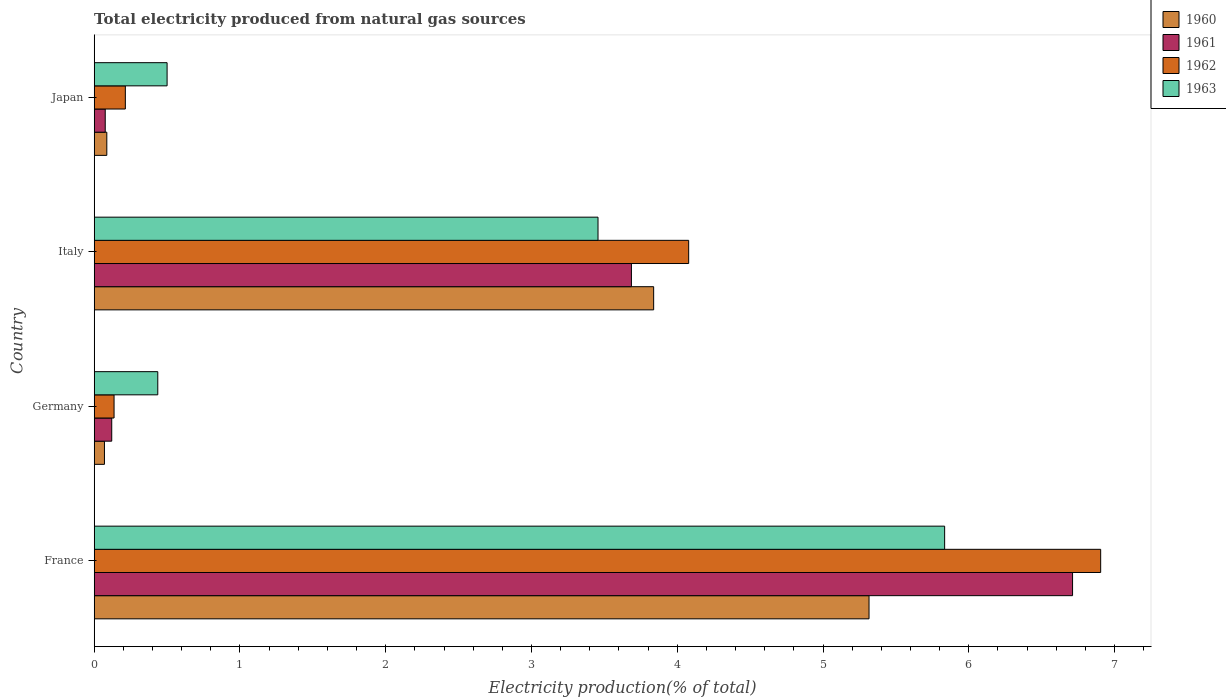How many different coloured bars are there?
Offer a terse response. 4. Are the number of bars per tick equal to the number of legend labels?
Make the answer very short. Yes. Are the number of bars on each tick of the Y-axis equal?
Your response must be concise. Yes. How many bars are there on the 2nd tick from the top?
Your answer should be compact. 4. What is the total electricity produced in 1960 in Germany?
Provide a short and direct response. 0.07. Across all countries, what is the maximum total electricity produced in 1960?
Keep it short and to the point. 5.32. Across all countries, what is the minimum total electricity produced in 1963?
Provide a short and direct response. 0.44. In which country was the total electricity produced in 1961 maximum?
Your answer should be compact. France. What is the total total electricity produced in 1961 in the graph?
Your response must be concise. 10.59. What is the difference between the total electricity produced in 1963 in France and that in Japan?
Your answer should be very brief. 5.33. What is the difference between the total electricity produced in 1960 in France and the total electricity produced in 1962 in Italy?
Provide a short and direct response. 1.24. What is the average total electricity produced in 1962 per country?
Your response must be concise. 2.83. What is the difference between the total electricity produced in 1963 and total electricity produced in 1962 in Germany?
Offer a terse response. 0.3. In how many countries, is the total electricity produced in 1963 greater than 0.2 %?
Keep it short and to the point. 4. What is the ratio of the total electricity produced in 1963 in Germany to that in Japan?
Your answer should be very brief. 0.87. Is the total electricity produced in 1961 in France less than that in Germany?
Offer a terse response. No. Is the difference between the total electricity produced in 1963 in Germany and Italy greater than the difference between the total electricity produced in 1962 in Germany and Italy?
Offer a very short reply. Yes. What is the difference between the highest and the second highest total electricity produced in 1962?
Keep it short and to the point. 2.83. What is the difference between the highest and the lowest total electricity produced in 1963?
Your answer should be very brief. 5.4. Is the sum of the total electricity produced in 1962 in France and Germany greater than the maximum total electricity produced in 1961 across all countries?
Make the answer very short. Yes. What does the 1st bar from the bottom in France represents?
Offer a very short reply. 1960. Is it the case that in every country, the sum of the total electricity produced in 1960 and total electricity produced in 1961 is greater than the total electricity produced in 1962?
Provide a succinct answer. No. Are all the bars in the graph horizontal?
Give a very brief answer. Yes. How many countries are there in the graph?
Your answer should be very brief. 4. What is the difference between two consecutive major ticks on the X-axis?
Your answer should be compact. 1. Are the values on the major ticks of X-axis written in scientific E-notation?
Your answer should be very brief. No. Does the graph contain grids?
Keep it short and to the point. No. What is the title of the graph?
Your answer should be very brief. Total electricity produced from natural gas sources. Does "1984" appear as one of the legend labels in the graph?
Keep it short and to the point. No. What is the label or title of the X-axis?
Provide a short and direct response. Electricity production(% of total). What is the label or title of the Y-axis?
Provide a short and direct response. Country. What is the Electricity production(% of total) of 1960 in France?
Your answer should be very brief. 5.32. What is the Electricity production(% of total) of 1961 in France?
Make the answer very short. 6.71. What is the Electricity production(% of total) in 1962 in France?
Offer a terse response. 6.91. What is the Electricity production(% of total) in 1963 in France?
Give a very brief answer. 5.83. What is the Electricity production(% of total) in 1960 in Germany?
Provide a succinct answer. 0.07. What is the Electricity production(% of total) in 1961 in Germany?
Provide a succinct answer. 0.12. What is the Electricity production(% of total) of 1962 in Germany?
Your response must be concise. 0.14. What is the Electricity production(% of total) in 1963 in Germany?
Keep it short and to the point. 0.44. What is the Electricity production(% of total) of 1960 in Italy?
Make the answer very short. 3.84. What is the Electricity production(% of total) of 1961 in Italy?
Offer a very short reply. 3.69. What is the Electricity production(% of total) of 1962 in Italy?
Provide a short and direct response. 4.08. What is the Electricity production(% of total) of 1963 in Italy?
Your answer should be compact. 3.46. What is the Electricity production(% of total) of 1960 in Japan?
Keep it short and to the point. 0.09. What is the Electricity production(% of total) of 1961 in Japan?
Make the answer very short. 0.08. What is the Electricity production(% of total) of 1962 in Japan?
Provide a succinct answer. 0.21. What is the Electricity production(% of total) of 1963 in Japan?
Your response must be concise. 0.5. Across all countries, what is the maximum Electricity production(% of total) in 1960?
Offer a terse response. 5.32. Across all countries, what is the maximum Electricity production(% of total) of 1961?
Your answer should be very brief. 6.71. Across all countries, what is the maximum Electricity production(% of total) in 1962?
Provide a short and direct response. 6.91. Across all countries, what is the maximum Electricity production(% of total) in 1963?
Your answer should be compact. 5.83. Across all countries, what is the minimum Electricity production(% of total) of 1960?
Your answer should be compact. 0.07. Across all countries, what is the minimum Electricity production(% of total) in 1961?
Give a very brief answer. 0.08. Across all countries, what is the minimum Electricity production(% of total) of 1962?
Your response must be concise. 0.14. Across all countries, what is the minimum Electricity production(% of total) of 1963?
Your answer should be very brief. 0.44. What is the total Electricity production(% of total) in 1960 in the graph?
Your response must be concise. 9.31. What is the total Electricity production(% of total) of 1961 in the graph?
Ensure brevity in your answer.  10.59. What is the total Electricity production(% of total) in 1962 in the graph?
Your response must be concise. 11.33. What is the total Electricity production(% of total) of 1963 in the graph?
Give a very brief answer. 10.23. What is the difference between the Electricity production(% of total) of 1960 in France and that in Germany?
Keep it short and to the point. 5.25. What is the difference between the Electricity production(% of total) in 1961 in France and that in Germany?
Give a very brief answer. 6.59. What is the difference between the Electricity production(% of total) in 1962 in France and that in Germany?
Ensure brevity in your answer.  6.77. What is the difference between the Electricity production(% of total) of 1963 in France and that in Germany?
Your response must be concise. 5.4. What is the difference between the Electricity production(% of total) of 1960 in France and that in Italy?
Your answer should be compact. 1.48. What is the difference between the Electricity production(% of total) in 1961 in France and that in Italy?
Provide a succinct answer. 3.03. What is the difference between the Electricity production(% of total) in 1962 in France and that in Italy?
Give a very brief answer. 2.83. What is the difference between the Electricity production(% of total) in 1963 in France and that in Italy?
Make the answer very short. 2.38. What is the difference between the Electricity production(% of total) of 1960 in France and that in Japan?
Make the answer very short. 5.23. What is the difference between the Electricity production(% of total) of 1961 in France and that in Japan?
Offer a very short reply. 6.64. What is the difference between the Electricity production(% of total) in 1962 in France and that in Japan?
Your answer should be compact. 6.69. What is the difference between the Electricity production(% of total) of 1963 in France and that in Japan?
Offer a terse response. 5.33. What is the difference between the Electricity production(% of total) of 1960 in Germany and that in Italy?
Provide a succinct answer. -3.77. What is the difference between the Electricity production(% of total) in 1961 in Germany and that in Italy?
Offer a very short reply. -3.57. What is the difference between the Electricity production(% of total) in 1962 in Germany and that in Italy?
Your answer should be compact. -3.94. What is the difference between the Electricity production(% of total) in 1963 in Germany and that in Italy?
Provide a short and direct response. -3.02. What is the difference between the Electricity production(% of total) of 1960 in Germany and that in Japan?
Make the answer very short. -0.02. What is the difference between the Electricity production(% of total) of 1961 in Germany and that in Japan?
Make the answer very short. 0.04. What is the difference between the Electricity production(% of total) of 1962 in Germany and that in Japan?
Provide a succinct answer. -0.08. What is the difference between the Electricity production(% of total) in 1963 in Germany and that in Japan?
Offer a very short reply. -0.06. What is the difference between the Electricity production(% of total) of 1960 in Italy and that in Japan?
Your response must be concise. 3.75. What is the difference between the Electricity production(% of total) of 1961 in Italy and that in Japan?
Keep it short and to the point. 3.61. What is the difference between the Electricity production(% of total) in 1962 in Italy and that in Japan?
Offer a very short reply. 3.86. What is the difference between the Electricity production(% of total) in 1963 in Italy and that in Japan?
Your response must be concise. 2.96. What is the difference between the Electricity production(% of total) in 1960 in France and the Electricity production(% of total) in 1961 in Germany?
Your answer should be very brief. 5.2. What is the difference between the Electricity production(% of total) in 1960 in France and the Electricity production(% of total) in 1962 in Germany?
Provide a short and direct response. 5.18. What is the difference between the Electricity production(% of total) in 1960 in France and the Electricity production(% of total) in 1963 in Germany?
Make the answer very short. 4.88. What is the difference between the Electricity production(% of total) of 1961 in France and the Electricity production(% of total) of 1962 in Germany?
Keep it short and to the point. 6.58. What is the difference between the Electricity production(% of total) in 1961 in France and the Electricity production(% of total) in 1963 in Germany?
Your response must be concise. 6.28. What is the difference between the Electricity production(% of total) in 1962 in France and the Electricity production(% of total) in 1963 in Germany?
Keep it short and to the point. 6.47. What is the difference between the Electricity production(% of total) of 1960 in France and the Electricity production(% of total) of 1961 in Italy?
Give a very brief answer. 1.63. What is the difference between the Electricity production(% of total) in 1960 in France and the Electricity production(% of total) in 1962 in Italy?
Provide a short and direct response. 1.24. What is the difference between the Electricity production(% of total) in 1960 in France and the Electricity production(% of total) in 1963 in Italy?
Your answer should be very brief. 1.86. What is the difference between the Electricity production(% of total) of 1961 in France and the Electricity production(% of total) of 1962 in Italy?
Your answer should be very brief. 2.63. What is the difference between the Electricity production(% of total) in 1961 in France and the Electricity production(% of total) in 1963 in Italy?
Provide a short and direct response. 3.26. What is the difference between the Electricity production(% of total) of 1962 in France and the Electricity production(% of total) of 1963 in Italy?
Provide a short and direct response. 3.45. What is the difference between the Electricity production(% of total) in 1960 in France and the Electricity production(% of total) in 1961 in Japan?
Provide a succinct answer. 5.24. What is the difference between the Electricity production(% of total) in 1960 in France and the Electricity production(% of total) in 1962 in Japan?
Provide a succinct answer. 5.1. What is the difference between the Electricity production(% of total) in 1960 in France and the Electricity production(% of total) in 1963 in Japan?
Your answer should be very brief. 4.82. What is the difference between the Electricity production(% of total) of 1961 in France and the Electricity production(% of total) of 1962 in Japan?
Provide a succinct answer. 6.5. What is the difference between the Electricity production(% of total) in 1961 in France and the Electricity production(% of total) in 1963 in Japan?
Provide a short and direct response. 6.21. What is the difference between the Electricity production(% of total) in 1962 in France and the Electricity production(% of total) in 1963 in Japan?
Ensure brevity in your answer.  6.4. What is the difference between the Electricity production(% of total) of 1960 in Germany and the Electricity production(% of total) of 1961 in Italy?
Your answer should be compact. -3.62. What is the difference between the Electricity production(% of total) in 1960 in Germany and the Electricity production(% of total) in 1962 in Italy?
Make the answer very short. -4.01. What is the difference between the Electricity production(% of total) in 1960 in Germany and the Electricity production(% of total) in 1963 in Italy?
Offer a very short reply. -3.39. What is the difference between the Electricity production(% of total) in 1961 in Germany and the Electricity production(% of total) in 1962 in Italy?
Provide a short and direct response. -3.96. What is the difference between the Electricity production(% of total) in 1961 in Germany and the Electricity production(% of total) in 1963 in Italy?
Make the answer very short. -3.34. What is the difference between the Electricity production(% of total) of 1962 in Germany and the Electricity production(% of total) of 1963 in Italy?
Offer a very short reply. -3.32. What is the difference between the Electricity production(% of total) in 1960 in Germany and the Electricity production(% of total) in 1961 in Japan?
Offer a terse response. -0.01. What is the difference between the Electricity production(% of total) of 1960 in Germany and the Electricity production(% of total) of 1962 in Japan?
Your answer should be compact. -0.14. What is the difference between the Electricity production(% of total) of 1960 in Germany and the Electricity production(% of total) of 1963 in Japan?
Your response must be concise. -0.43. What is the difference between the Electricity production(% of total) of 1961 in Germany and the Electricity production(% of total) of 1962 in Japan?
Your response must be concise. -0.09. What is the difference between the Electricity production(% of total) of 1961 in Germany and the Electricity production(% of total) of 1963 in Japan?
Give a very brief answer. -0.38. What is the difference between the Electricity production(% of total) of 1962 in Germany and the Electricity production(% of total) of 1963 in Japan?
Your answer should be very brief. -0.36. What is the difference between the Electricity production(% of total) of 1960 in Italy and the Electricity production(% of total) of 1961 in Japan?
Provide a succinct answer. 3.76. What is the difference between the Electricity production(% of total) in 1960 in Italy and the Electricity production(% of total) in 1962 in Japan?
Give a very brief answer. 3.62. What is the difference between the Electricity production(% of total) in 1960 in Italy and the Electricity production(% of total) in 1963 in Japan?
Your response must be concise. 3.34. What is the difference between the Electricity production(% of total) in 1961 in Italy and the Electricity production(% of total) in 1962 in Japan?
Make the answer very short. 3.47. What is the difference between the Electricity production(% of total) of 1961 in Italy and the Electricity production(% of total) of 1963 in Japan?
Provide a short and direct response. 3.19. What is the difference between the Electricity production(% of total) in 1962 in Italy and the Electricity production(% of total) in 1963 in Japan?
Give a very brief answer. 3.58. What is the average Electricity production(% of total) of 1960 per country?
Provide a succinct answer. 2.33. What is the average Electricity production(% of total) of 1961 per country?
Your response must be concise. 2.65. What is the average Electricity production(% of total) in 1962 per country?
Offer a terse response. 2.83. What is the average Electricity production(% of total) in 1963 per country?
Ensure brevity in your answer.  2.56. What is the difference between the Electricity production(% of total) in 1960 and Electricity production(% of total) in 1961 in France?
Make the answer very short. -1.4. What is the difference between the Electricity production(% of total) of 1960 and Electricity production(% of total) of 1962 in France?
Offer a terse response. -1.59. What is the difference between the Electricity production(% of total) in 1960 and Electricity production(% of total) in 1963 in France?
Offer a terse response. -0.52. What is the difference between the Electricity production(% of total) in 1961 and Electricity production(% of total) in 1962 in France?
Ensure brevity in your answer.  -0.19. What is the difference between the Electricity production(% of total) of 1961 and Electricity production(% of total) of 1963 in France?
Your answer should be very brief. 0.88. What is the difference between the Electricity production(% of total) of 1962 and Electricity production(% of total) of 1963 in France?
Ensure brevity in your answer.  1.07. What is the difference between the Electricity production(% of total) in 1960 and Electricity production(% of total) in 1962 in Germany?
Ensure brevity in your answer.  -0.07. What is the difference between the Electricity production(% of total) of 1960 and Electricity production(% of total) of 1963 in Germany?
Make the answer very short. -0.37. What is the difference between the Electricity production(% of total) of 1961 and Electricity production(% of total) of 1962 in Germany?
Give a very brief answer. -0.02. What is the difference between the Electricity production(% of total) in 1961 and Electricity production(% of total) in 1963 in Germany?
Your response must be concise. -0.32. What is the difference between the Electricity production(% of total) of 1962 and Electricity production(% of total) of 1963 in Germany?
Your answer should be compact. -0.3. What is the difference between the Electricity production(% of total) of 1960 and Electricity production(% of total) of 1961 in Italy?
Your answer should be very brief. 0.15. What is the difference between the Electricity production(% of total) in 1960 and Electricity production(% of total) in 1962 in Italy?
Offer a very short reply. -0.24. What is the difference between the Electricity production(% of total) in 1960 and Electricity production(% of total) in 1963 in Italy?
Your answer should be very brief. 0.38. What is the difference between the Electricity production(% of total) in 1961 and Electricity production(% of total) in 1962 in Italy?
Ensure brevity in your answer.  -0.39. What is the difference between the Electricity production(% of total) of 1961 and Electricity production(% of total) of 1963 in Italy?
Provide a short and direct response. 0.23. What is the difference between the Electricity production(% of total) in 1962 and Electricity production(% of total) in 1963 in Italy?
Provide a short and direct response. 0.62. What is the difference between the Electricity production(% of total) in 1960 and Electricity production(% of total) in 1961 in Japan?
Provide a succinct answer. 0.01. What is the difference between the Electricity production(% of total) in 1960 and Electricity production(% of total) in 1962 in Japan?
Provide a succinct answer. -0.13. What is the difference between the Electricity production(% of total) of 1960 and Electricity production(% of total) of 1963 in Japan?
Make the answer very short. -0.41. What is the difference between the Electricity production(% of total) in 1961 and Electricity production(% of total) in 1962 in Japan?
Your response must be concise. -0.14. What is the difference between the Electricity production(% of total) in 1961 and Electricity production(% of total) in 1963 in Japan?
Provide a succinct answer. -0.42. What is the difference between the Electricity production(% of total) of 1962 and Electricity production(% of total) of 1963 in Japan?
Offer a terse response. -0.29. What is the ratio of the Electricity production(% of total) in 1960 in France to that in Germany?
Provide a succinct answer. 75.62. What is the ratio of the Electricity production(% of total) of 1961 in France to that in Germany?
Offer a terse response. 55.79. What is the ratio of the Electricity production(% of total) in 1962 in France to that in Germany?
Your answer should be very brief. 50.69. What is the ratio of the Electricity production(% of total) in 1963 in France to that in Germany?
Ensure brevity in your answer.  13.38. What is the ratio of the Electricity production(% of total) of 1960 in France to that in Italy?
Your answer should be very brief. 1.39. What is the ratio of the Electricity production(% of total) of 1961 in France to that in Italy?
Your response must be concise. 1.82. What is the ratio of the Electricity production(% of total) of 1962 in France to that in Italy?
Provide a succinct answer. 1.69. What is the ratio of the Electricity production(% of total) of 1963 in France to that in Italy?
Provide a succinct answer. 1.69. What is the ratio of the Electricity production(% of total) of 1960 in France to that in Japan?
Keep it short and to the point. 61.4. What is the ratio of the Electricity production(% of total) of 1961 in France to that in Japan?
Keep it short and to the point. 88.67. What is the ratio of the Electricity production(% of total) of 1962 in France to that in Japan?
Ensure brevity in your answer.  32.32. What is the ratio of the Electricity production(% of total) of 1963 in France to that in Japan?
Your answer should be compact. 11.67. What is the ratio of the Electricity production(% of total) of 1960 in Germany to that in Italy?
Offer a very short reply. 0.02. What is the ratio of the Electricity production(% of total) of 1961 in Germany to that in Italy?
Offer a very short reply. 0.03. What is the ratio of the Electricity production(% of total) of 1962 in Germany to that in Italy?
Keep it short and to the point. 0.03. What is the ratio of the Electricity production(% of total) in 1963 in Germany to that in Italy?
Your answer should be compact. 0.13. What is the ratio of the Electricity production(% of total) of 1960 in Germany to that in Japan?
Your response must be concise. 0.81. What is the ratio of the Electricity production(% of total) of 1961 in Germany to that in Japan?
Give a very brief answer. 1.59. What is the ratio of the Electricity production(% of total) of 1962 in Germany to that in Japan?
Your answer should be very brief. 0.64. What is the ratio of the Electricity production(% of total) of 1963 in Germany to that in Japan?
Your response must be concise. 0.87. What is the ratio of the Electricity production(% of total) of 1960 in Italy to that in Japan?
Offer a very short reply. 44.33. What is the ratio of the Electricity production(% of total) in 1961 in Italy to that in Japan?
Make the answer very short. 48.69. What is the ratio of the Electricity production(% of total) of 1962 in Italy to that in Japan?
Offer a very short reply. 19.09. What is the ratio of the Electricity production(% of total) in 1963 in Italy to that in Japan?
Provide a short and direct response. 6.91. What is the difference between the highest and the second highest Electricity production(% of total) of 1960?
Give a very brief answer. 1.48. What is the difference between the highest and the second highest Electricity production(% of total) of 1961?
Your answer should be very brief. 3.03. What is the difference between the highest and the second highest Electricity production(% of total) of 1962?
Ensure brevity in your answer.  2.83. What is the difference between the highest and the second highest Electricity production(% of total) in 1963?
Ensure brevity in your answer.  2.38. What is the difference between the highest and the lowest Electricity production(% of total) in 1960?
Ensure brevity in your answer.  5.25. What is the difference between the highest and the lowest Electricity production(% of total) in 1961?
Provide a short and direct response. 6.64. What is the difference between the highest and the lowest Electricity production(% of total) of 1962?
Provide a short and direct response. 6.77. What is the difference between the highest and the lowest Electricity production(% of total) in 1963?
Offer a very short reply. 5.4. 